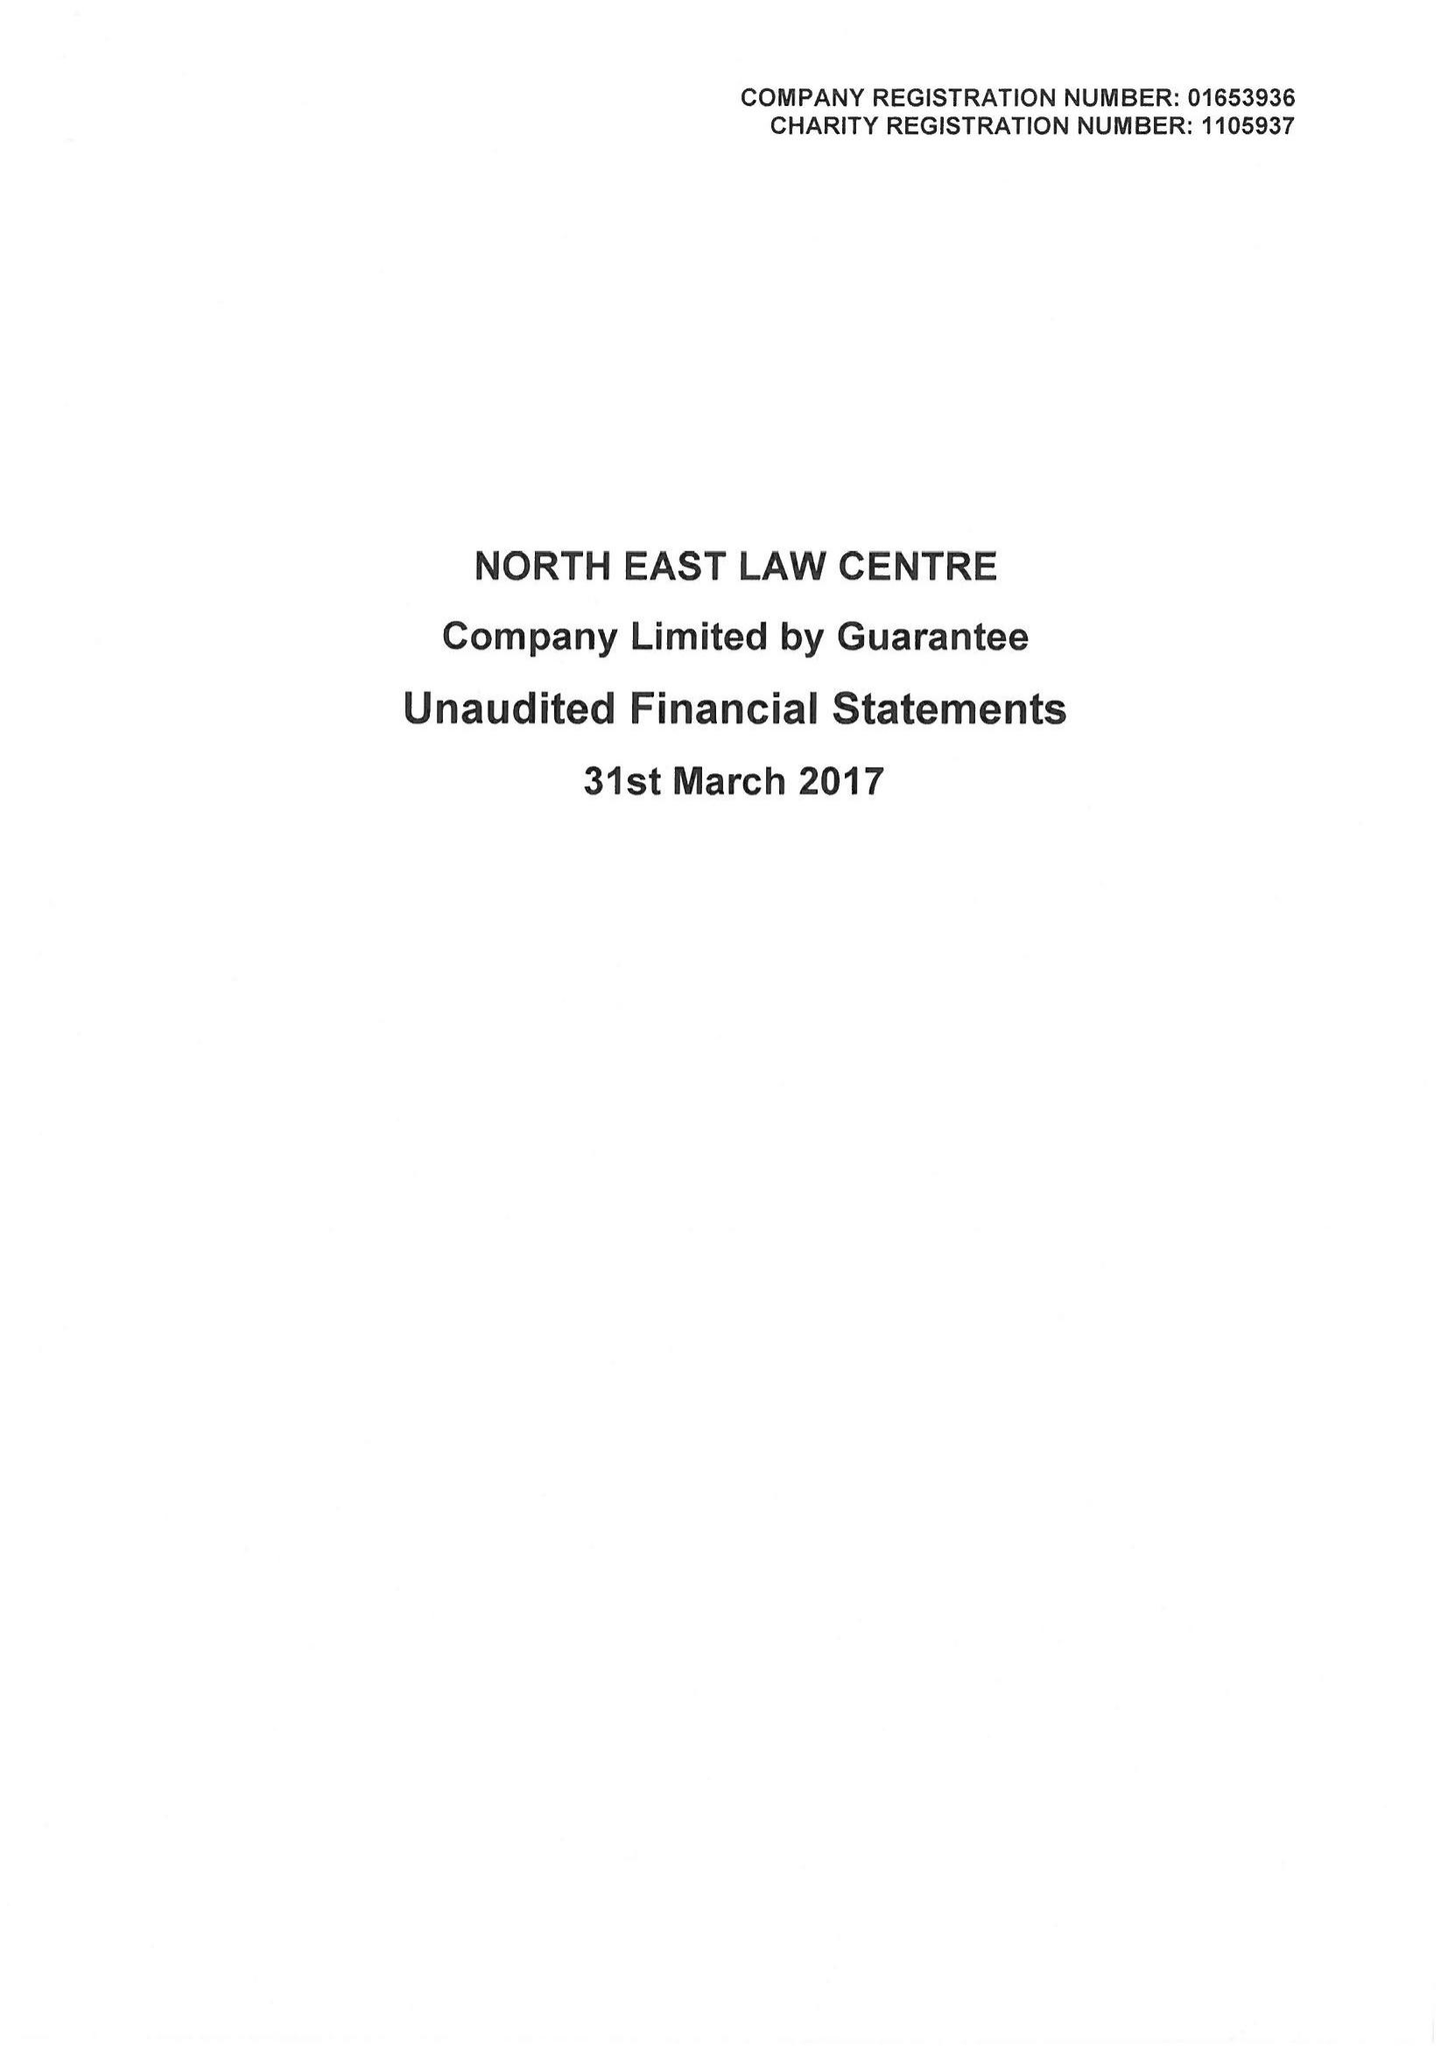What is the value for the address__street_line?
Answer the question using a single word or phrase. ELLISON PLACE 